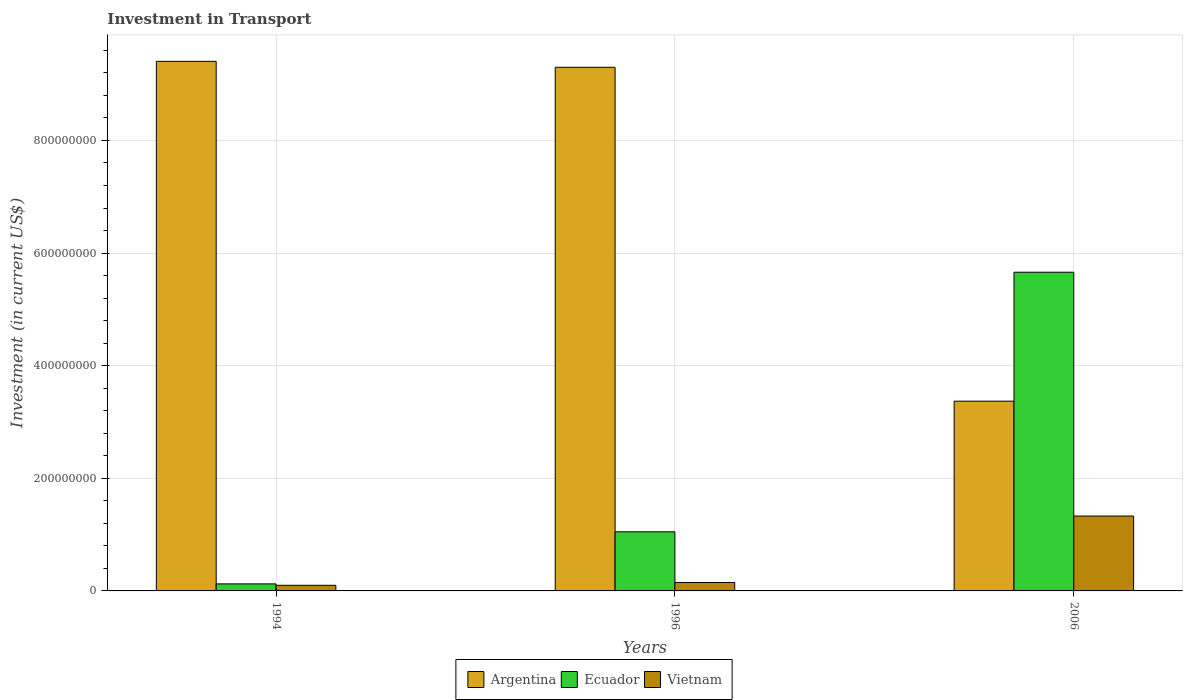How many groups of bars are there?
Offer a terse response. 3. Are the number of bars per tick equal to the number of legend labels?
Offer a terse response. Yes. Are the number of bars on each tick of the X-axis equal?
Keep it short and to the point. Yes. How many bars are there on the 3rd tick from the left?
Offer a terse response. 3. What is the label of the 3rd group of bars from the left?
Offer a terse response. 2006. What is the amount invested in transport in Argentina in 2006?
Your answer should be compact. 3.37e+08. Across all years, what is the maximum amount invested in transport in Vietnam?
Make the answer very short. 1.33e+08. What is the total amount invested in transport in Vietnam in the graph?
Your answer should be compact. 1.58e+08. What is the difference between the amount invested in transport in Argentina in 1996 and that in 2006?
Your answer should be compact. 5.93e+08. What is the difference between the amount invested in transport in Argentina in 2006 and the amount invested in transport in Vietnam in 1996?
Make the answer very short. 3.22e+08. What is the average amount invested in transport in Vietnam per year?
Give a very brief answer. 5.27e+07. In the year 1996, what is the difference between the amount invested in transport in Ecuador and amount invested in transport in Vietnam?
Your answer should be compact. 9.00e+07. What is the ratio of the amount invested in transport in Argentina in 1994 to that in 1996?
Give a very brief answer. 1.01. Is the amount invested in transport in Argentina in 1994 less than that in 1996?
Make the answer very short. No. What is the difference between the highest and the second highest amount invested in transport in Ecuador?
Ensure brevity in your answer.  4.61e+08. What is the difference between the highest and the lowest amount invested in transport in Argentina?
Give a very brief answer. 6.04e+08. In how many years, is the amount invested in transport in Argentina greater than the average amount invested in transport in Argentina taken over all years?
Your answer should be compact. 2. What does the 1st bar from the right in 1994 represents?
Provide a succinct answer. Vietnam. How many bars are there?
Provide a short and direct response. 9. Are all the bars in the graph horizontal?
Keep it short and to the point. No. Are the values on the major ticks of Y-axis written in scientific E-notation?
Keep it short and to the point. No. Does the graph contain any zero values?
Make the answer very short. No. Where does the legend appear in the graph?
Offer a very short reply. Bottom center. How many legend labels are there?
Provide a short and direct response. 3. What is the title of the graph?
Ensure brevity in your answer.  Investment in Transport. Does "Northern Mariana Islands" appear as one of the legend labels in the graph?
Your response must be concise. No. What is the label or title of the X-axis?
Give a very brief answer. Years. What is the label or title of the Y-axis?
Your answer should be very brief. Investment (in current US$). What is the Investment (in current US$) in Argentina in 1994?
Your response must be concise. 9.40e+08. What is the Investment (in current US$) of Ecuador in 1994?
Your response must be concise. 1.25e+07. What is the Investment (in current US$) of Vietnam in 1994?
Your response must be concise. 1.00e+07. What is the Investment (in current US$) of Argentina in 1996?
Give a very brief answer. 9.30e+08. What is the Investment (in current US$) of Ecuador in 1996?
Make the answer very short. 1.05e+08. What is the Investment (in current US$) of Vietnam in 1996?
Provide a succinct answer. 1.50e+07. What is the Investment (in current US$) of Argentina in 2006?
Make the answer very short. 3.37e+08. What is the Investment (in current US$) of Ecuador in 2006?
Give a very brief answer. 5.66e+08. What is the Investment (in current US$) of Vietnam in 2006?
Provide a short and direct response. 1.33e+08. Across all years, what is the maximum Investment (in current US$) in Argentina?
Keep it short and to the point. 9.40e+08. Across all years, what is the maximum Investment (in current US$) in Ecuador?
Provide a succinct answer. 5.66e+08. Across all years, what is the maximum Investment (in current US$) in Vietnam?
Offer a terse response. 1.33e+08. Across all years, what is the minimum Investment (in current US$) of Argentina?
Offer a terse response. 3.37e+08. Across all years, what is the minimum Investment (in current US$) of Ecuador?
Provide a succinct answer. 1.25e+07. What is the total Investment (in current US$) in Argentina in the graph?
Offer a terse response. 2.21e+09. What is the total Investment (in current US$) in Ecuador in the graph?
Ensure brevity in your answer.  6.84e+08. What is the total Investment (in current US$) of Vietnam in the graph?
Offer a terse response. 1.58e+08. What is the difference between the Investment (in current US$) in Argentina in 1994 and that in 1996?
Provide a short and direct response. 1.05e+07. What is the difference between the Investment (in current US$) of Ecuador in 1994 and that in 1996?
Ensure brevity in your answer.  -9.25e+07. What is the difference between the Investment (in current US$) of Vietnam in 1994 and that in 1996?
Provide a succinct answer. -5.00e+06. What is the difference between the Investment (in current US$) in Argentina in 1994 and that in 2006?
Ensure brevity in your answer.  6.04e+08. What is the difference between the Investment (in current US$) of Ecuador in 1994 and that in 2006?
Make the answer very short. -5.54e+08. What is the difference between the Investment (in current US$) of Vietnam in 1994 and that in 2006?
Offer a terse response. -1.23e+08. What is the difference between the Investment (in current US$) in Argentina in 1996 and that in 2006?
Offer a terse response. 5.93e+08. What is the difference between the Investment (in current US$) of Ecuador in 1996 and that in 2006?
Provide a short and direct response. -4.61e+08. What is the difference between the Investment (in current US$) in Vietnam in 1996 and that in 2006?
Your answer should be very brief. -1.18e+08. What is the difference between the Investment (in current US$) of Argentina in 1994 and the Investment (in current US$) of Ecuador in 1996?
Your answer should be compact. 8.36e+08. What is the difference between the Investment (in current US$) in Argentina in 1994 and the Investment (in current US$) in Vietnam in 1996?
Give a very brief answer. 9.26e+08. What is the difference between the Investment (in current US$) of Ecuador in 1994 and the Investment (in current US$) of Vietnam in 1996?
Your response must be concise. -2.50e+06. What is the difference between the Investment (in current US$) in Argentina in 1994 and the Investment (in current US$) in Ecuador in 2006?
Keep it short and to the point. 3.74e+08. What is the difference between the Investment (in current US$) in Argentina in 1994 and the Investment (in current US$) in Vietnam in 2006?
Your response must be concise. 8.08e+08. What is the difference between the Investment (in current US$) of Ecuador in 1994 and the Investment (in current US$) of Vietnam in 2006?
Provide a short and direct response. -1.20e+08. What is the difference between the Investment (in current US$) of Argentina in 1996 and the Investment (in current US$) of Ecuador in 2006?
Make the answer very short. 3.64e+08. What is the difference between the Investment (in current US$) in Argentina in 1996 and the Investment (in current US$) in Vietnam in 2006?
Provide a short and direct response. 7.97e+08. What is the difference between the Investment (in current US$) in Ecuador in 1996 and the Investment (in current US$) in Vietnam in 2006?
Give a very brief answer. -2.80e+07. What is the average Investment (in current US$) in Argentina per year?
Provide a short and direct response. 7.36e+08. What is the average Investment (in current US$) of Ecuador per year?
Offer a terse response. 2.28e+08. What is the average Investment (in current US$) of Vietnam per year?
Provide a succinct answer. 5.27e+07. In the year 1994, what is the difference between the Investment (in current US$) in Argentina and Investment (in current US$) in Ecuador?
Provide a succinct answer. 9.28e+08. In the year 1994, what is the difference between the Investment (in current US$) in Argentina and Investment (in current US$) in Vietnam?
Keep it short and to the point. 9.30e+08. In the year 1994, what is the difference between the Investment (in current US$) in Ecuador and Investment (in current US$) in Vietnam?
Give a very brief answer. 2.50e+06. In the year 1996, what is the difference between the Investment (in current US$) of Argentina and Investment (in current US$) of Ecuador?
Your response must be concise. 8.25e+08. In the year 1996, what is the difference between the Investment (in current US$) in Argentina and Investment (in current US$) in Vietnam?
Ensure brevity in your answer.  9.15e+08. In the year 1996, what is the difference between the Investment (in current US$) of Ecuador and Investment (in current US$) of Vietnam?
Offer a terse response. 9.00e+07. In the year 2006, what is the difference between the Investment (in current US$) in Argentina and Investment (in current US$) in Ecuador?
Your answer should be compact. -2.29e+08. In the year 2006, what is the difference between the Investment (in current US$) in Argentina and Investment (in current US$) in Vietnam?
Make the answer very short. 2.04e+08. In the year 2006, what is the difference between the Investment (in current US$) in Ecuador and Investment (in current US$) in Vietnam?
Your answer should be compact. 4.33e+08. What is the ratio of the Investment (in current US$) in Argentina in 1994 to that in 1996?
Offer a very short reply. 1.01. What is the ratio of the Investment (in current US$) in Ecuador in 1994 to that in 1996?
Offer a terse response. 0.12. What is the ratio of the Investment (in current US$) of Vietnam in 1994 to that in 1996?
Make the answer very short. 0.67. What is the ratio of the Investment (in current US$) in Argentina in 1994 to that in 2006?
Give a very brief answer. 2.79. What is the ratio of the Investment (in current US$) in Ecuador in 1994 to that in 2006?
Give a very brief answer. 0.02. What is the ratio of the Investment (in current US$) in Vietnam in 1994 to that in 2006?
Keep it short and to the point. 0.08. What is the ratio of the Investment (in current US$) of Argentina in 1996 to that in 2006?
Your response must be concise. 2.76. What is the ratio of the Investment (in current US$) of Ecuador in 1996 to that in 2006?
Ensure brevity in your answer.  0.19. What is the ratio of the Investment (in current US$) in Vietnam in 1996 to that in 2006?
Your response must be concise. 0.11. What is the difference between the highest and the second highest Investment (in current US$) in Argentina?
Your response must be concise. 1.05e+07. What is the difference between the highest and the second highest Investment (in current US$) of Ecuador?
Provide a short and direct response. 4.61e+08. What is the difference between the highest and the second highest Investment (in current US$) in Vietnam?
Offer a very short reply. 1.18e+08. What is the difference between the highest and the lowest Investment (in current US$) of Argentina?
Ensure brevity in your answer.  6.04e+08. What is the difference between the highest and the lowest Investment (in current US$) in Ecuador?
Your response must be concise. 5.54e+08. What is the difference between the highest and the lowest Investment (in current US$) of Vietnam?
Make the answer very short. 1.23e+08. 